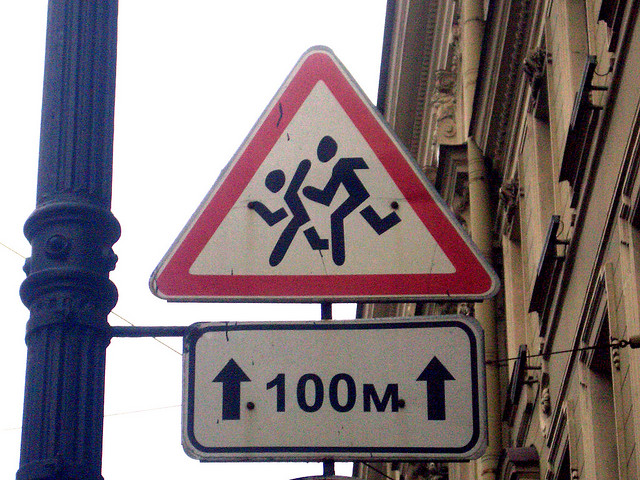Identify the text displayed in this image. 100 M. 